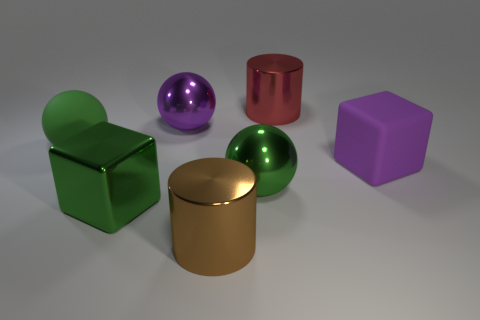Subtract all green spheres. How many spheres are left? 1 Subtract all brown cubes. How many green spheres are left? 2 Add 2 rubber objects. How many objects exist? 9 Subtract all blocks. How many objects are left? 5 Subtract all purple spheres. How many spheres are left? 2 Subtract all blue balls. Subtract all brown cylinders. How many balls are left? 3 Subtract 0 red balls. How many objects are left? 7 Subtract all green spheres. Subtract all purple things. How many objects are left? 3 Add 5 large purple cubes. How many large purple cubes are left? 6 Add 5 cyan objects. How many cyan objects exist? 5 